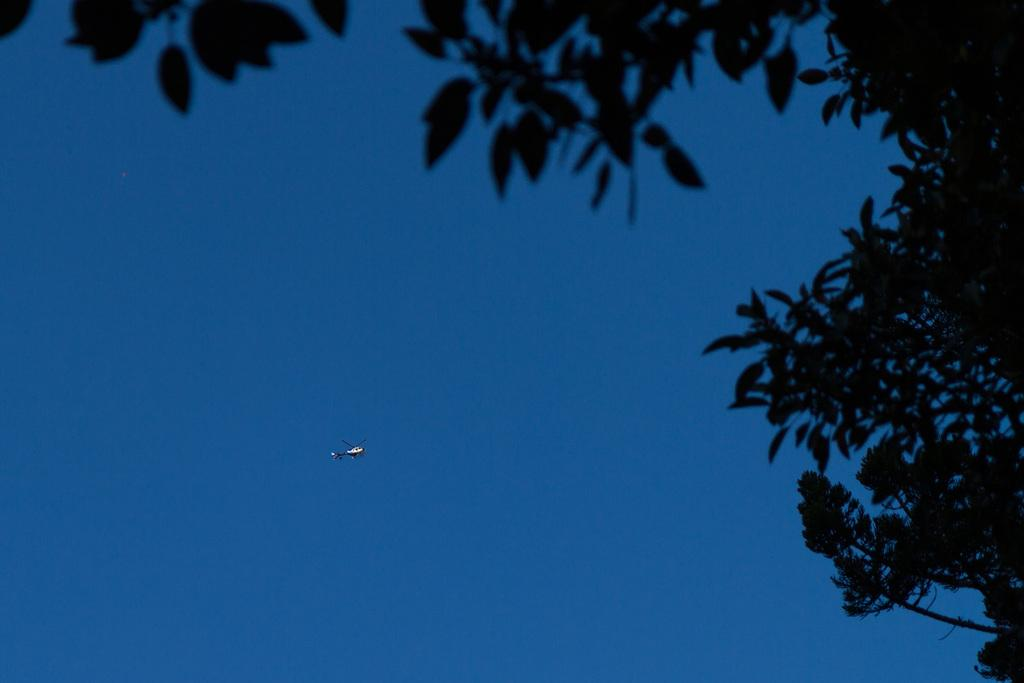What is flying in the sky in the image? A helicopter is flying in the sky in the image. What can be seen in the background of the image? There are trees visible in the image. Where is the vase located in the image? There is no vase present in the image. Is there any blood visible in the image? There is no blood visible in the image. 